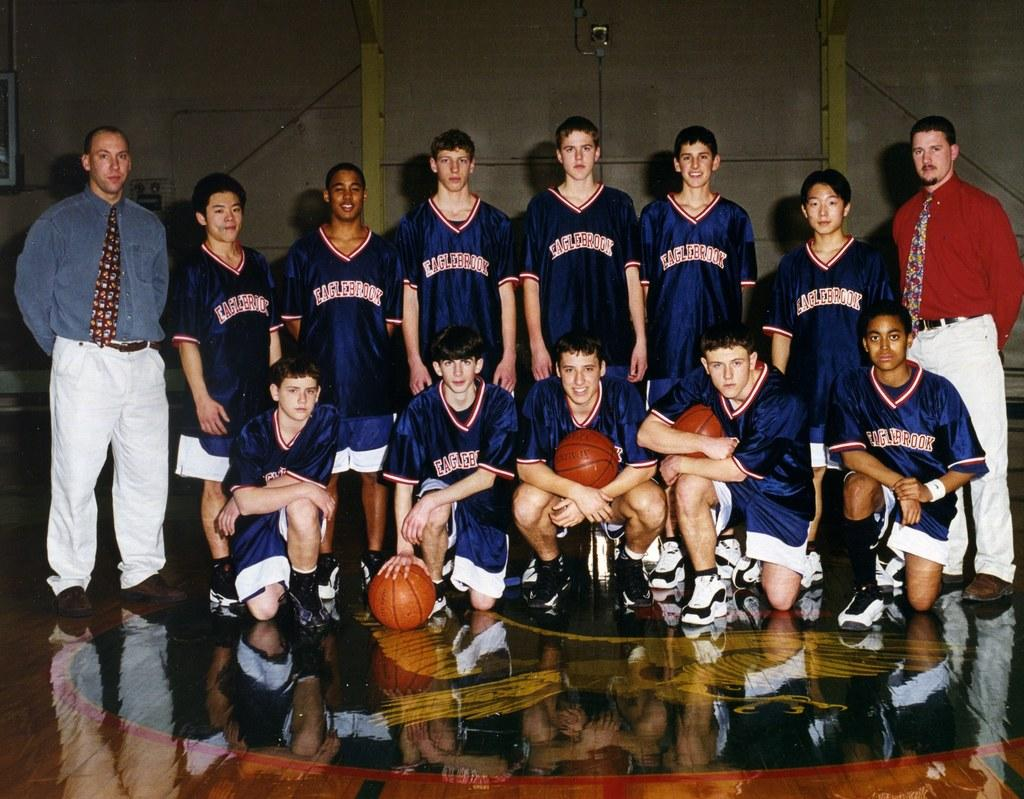Provide a one-sentence caption for the provided image. The basketball team from Eaglebrook poses for their photograph. 